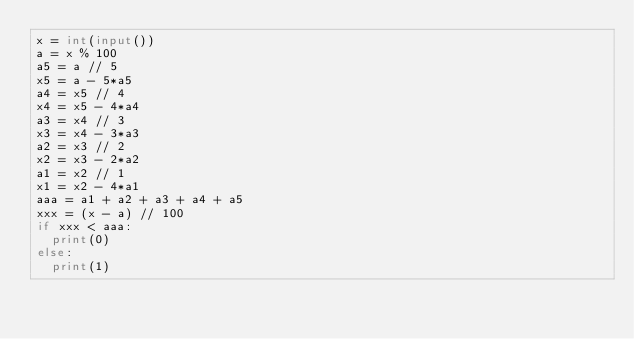<code> <loc_0><loc_0><loc_500><loc_500><_Python_>x = int(input())
a = x % 100
a5 = a // 5
x5 = a - 5*a5
a4 = x5 // 4
x4 = x5 - 4*a4
a3 = x4 // 3
x3 = x4 - 3*a3
a2 = x3 // 2
x2 = x3 - 2*a2
a1 = x2 // 1
x1 = x2 - 4*a1
aaa = a1 + a2 + a3 + a4 + a5
xxx = (x - a) // 100
if xxx < aaa:
  print(0)
else:
  print(1)</code> 